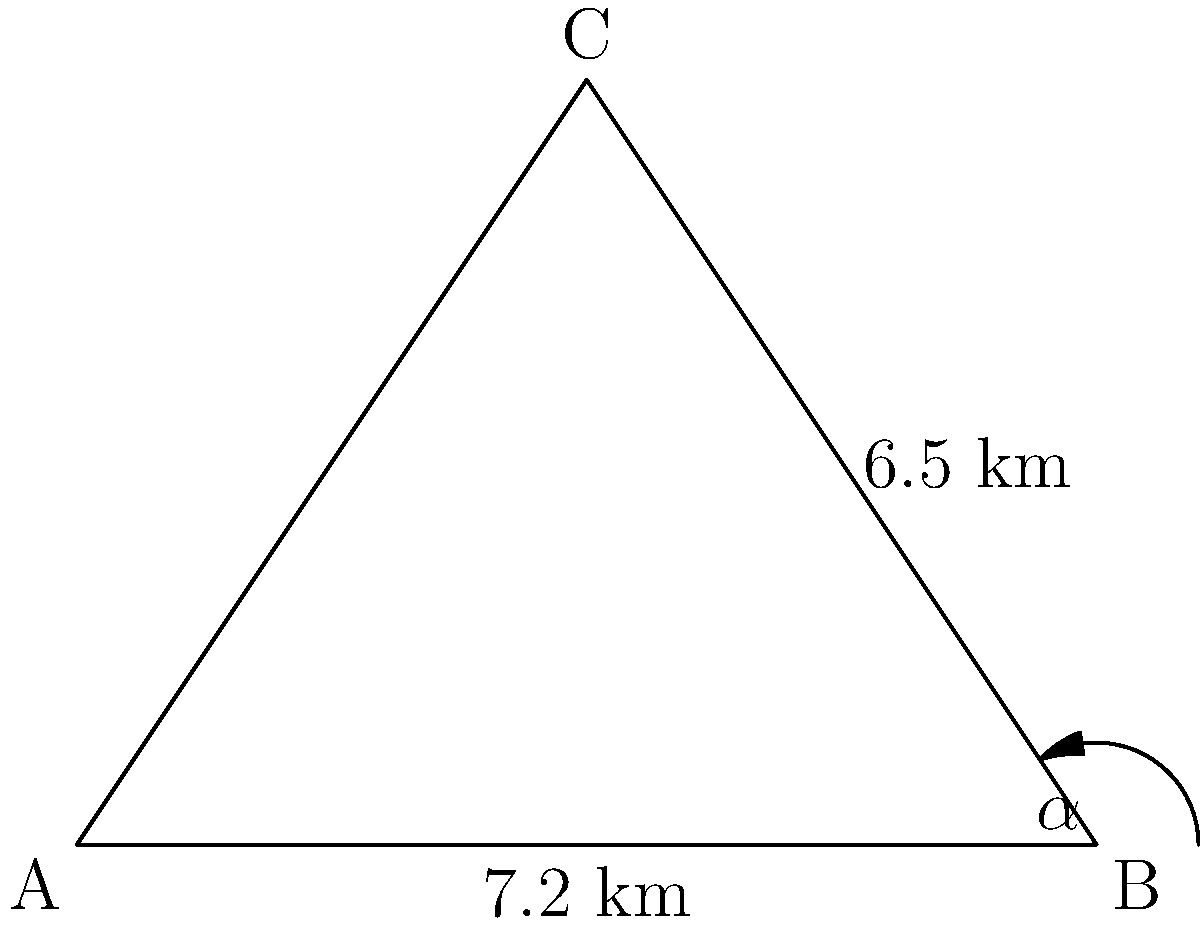In the disputed Southeast Peninsula region, a proposed border fence needs to be constructed along the side AC of the triangular area ABC. Given that AB = 7.2 km, BC = 6.5 km, and angle $\alpha$ at B is 53°, calculate the length of the proposed fence (AC) using the law of cosines. To solve this problem, we'll use the law of cosines:

$c^2 = a^2 + b^2 - 2ab \cos(C)$

Where:
$c$ is the length of AC (the side we're looking for)
$a$ is the length of BC (6.5 km)
$b$ is the length of AB (7.2 km)
$C$ is the angle at B (53°)

Step 1: Plug the known values into the formula:
$c^2 = 6.5^2 + 7.2^2 - 2(6.5)(7.2) \cos(53°)$

Step 2: Calculate the cosine of 53°:
$\cos(53°) \approx 0.6018$

Step 3: Solve the equation:
$c^2 = 42.25 + 51.84 - 2(6.5)(7.2)(0.6018)$
$c^2 = 94.09 - 56.33$
$c^2 = 37.76$

Step 4: Take the square root of both sides:
$c = \sqrt{37.76} \approx 6.15$

Therefore, the length of the proposed fence (AC) is approximately 6.15 km.
Answer: 6.15 km 